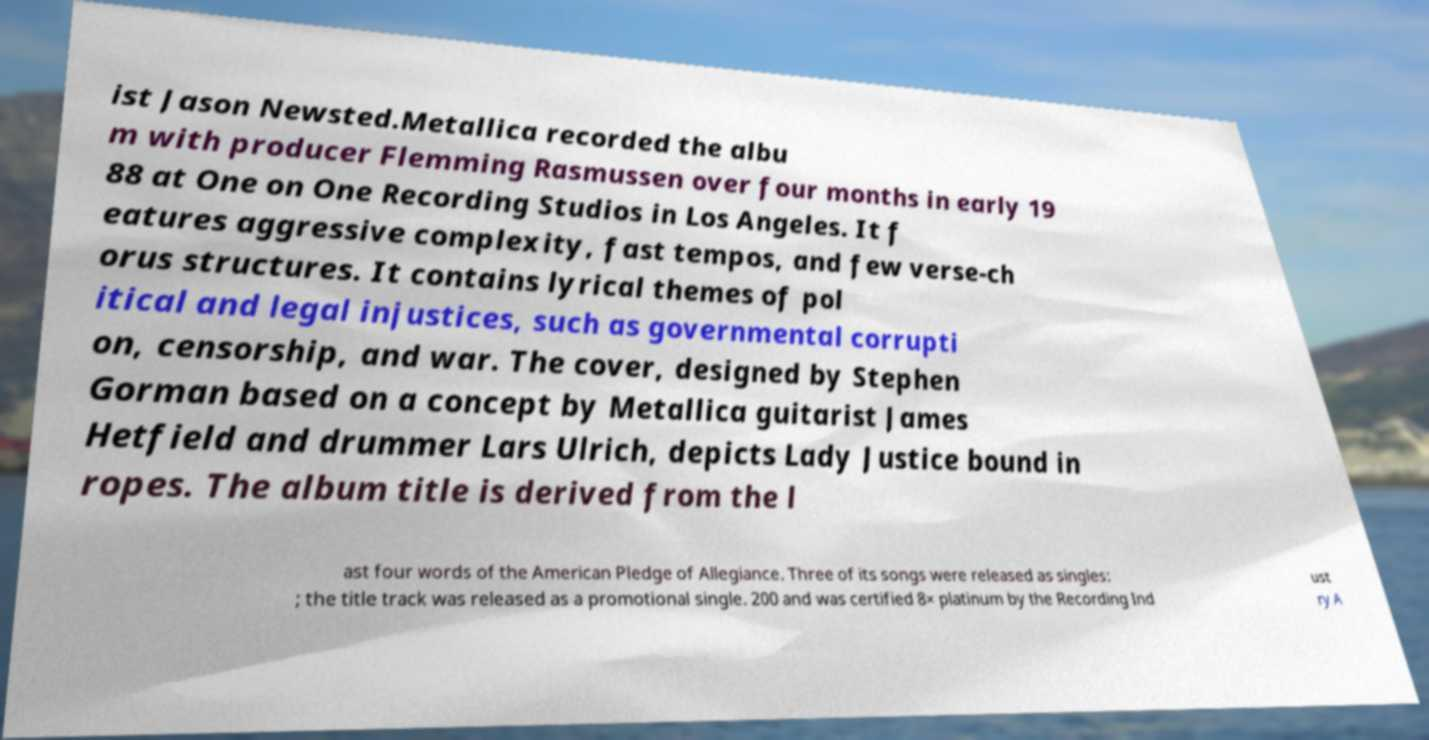Please read and relay the text visible in this image. What does it say? ist Jason Newsted.Metallica recorded the albu m with producer Flemming Rasmussen over four months in early 19 88 at One on One Recording Studios in Los Angeles. It f eatures aggressive complexity, fast tempos, and few verse-ch orus structures. It contains lyrical themes of pol itical and legal injustices, such as governmental corrupti on, censorship, and war. The cover, designed by Stephen Gorman based on a concept by Metallica guitarist James Hetfield and drummer Lars Ulrich, depicts Lady Justice bound in ropes. The album title is derived from the l ast four words of the American Pledge of Allegiance. Three of its songs were released as singles: ; the title track was released as a promotional single. 200 and was certified 8× platinum by the Recording Ind ust ry A 